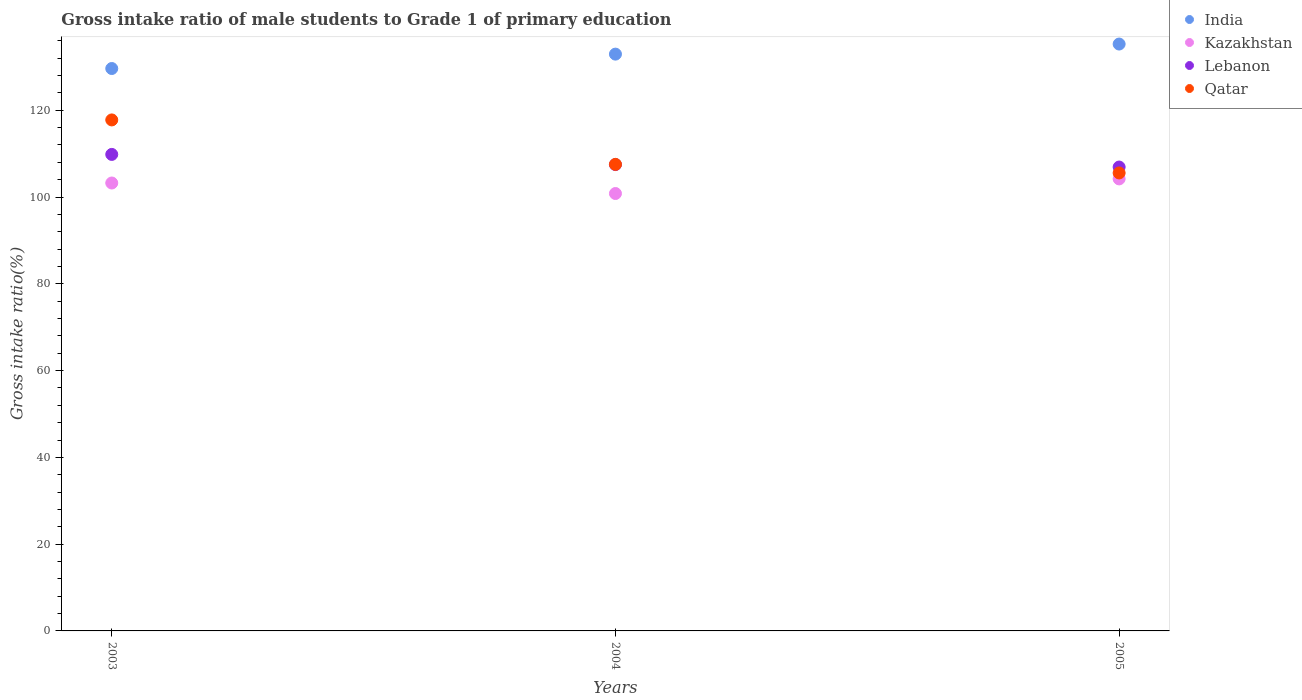How many different coloured dotlines are there?
Provide a short and direct response. 4. What is the gross intake ratio in Lebanon in 2004?
Provide a short and direct response. 107.49. Across all years, what is the maximum gross intake ratio in Kazakhstan?
Make the answer very short. 104.18. Across all years, what is the minimum gross intake ratio in Qatar?
Offer a terse response. 105.56. What is the total gross intake ratio in Lebanon in the graph?
Provide a succinct answer. 324.24. What is the difference between the gross intake ratio in Qatar in 2003 and that in 2004?
Ensure brevity in your answer.  10.24. What is the difference between the gross intake ratio in Lebanon in 2004 and the gross intake ratio in Qatar in 2003?
Give a very brief answer. -10.29. What is the average gross intake ratio in Lebanon per year?
Make the answer very short. 108.08. In the year 2005, what is the difference between the gross intake ratio in India and gross intake ratio in Qatar?
Keep it short and to the point. 29.71. In how many years, is the gross intake ratio in Lebanon greater than 88 %?
Your answer should be very brief. 3. What is the ratio of the gross intake ratio in Qatar in 2003 to that in 2005?
Provide a short and direct response. 1.12. Is the difference between the gross intake ratio in India in 2004 and 2005 greater than the difference between the gross intake ratio in Qatar in 2004 and 2005?
Give a very brief answer. No. What is the difference between the highest and the second highest gross intake ratio in Lebanon?
Offer a very short reply. 2.34. What is the difference between the highest and the lowest gross intake ratio in Kazakhstan?
Keep it short and to the point. 3.37. Is the sum of the gross intake ratio in Kazakhstan in 2004 and 2005 greater than the maximum gross intake ratio in Qatar across all years?
Ensure brevity in your answer.  Yes. Is it the case that in every year, the sum of the gross intake ratio in India and gross intake ratio in Lebanon  is greater than the sum of gross intake ratio in Qatar and gross intake ratio in Kazakhstan?
Give a very brief answer. Yes. Is the gross intake ratio in Qatar strictly greater than the gross intake ratio in Lebanon over the years?
Keep it short and to the point. No. How many dotlines are there?
Your answer should be compact. 4. What is the difference between two consecutive major ticks on the Y-axis?
Offer a terse response. 20. Does the graph contain any zero values?
Give a very brief answer. No. Does the graph contain grids?
Provide a short and direct response. No. Where does the legend appear in the graph?
Provide a succinct answer. Top right. What is the title of the graph?
Offer a terse response. Gross intake ratio of male students to Grade 1 of primary education. Does "Mali" appear as one of the legend labels in the graph?
Your answer should be compact. No. What is the label or title of the Y-axis?
Your answer should be compact. Gross intake ratio(%). What is the Gross intake ratio(%) in India in 2003?
Your response must be concise. 129.63. What is the Gross intake ratio(%) of Kazakhstan in 2003?
Give a very brief answer. 103.24. What is the Gross intake ratio(%) in Lebanon in 2003?
Your response must be concise. 109.83. What is the Gross intake ratio(%) in Qatar in 2003?
Keep it short and to the point. 117.78. What is the Gross intake ratio(%) of India in 2004?
Make the answer very short. 132.94. What is the Gross intake ratio(%) in Kazakhstan in 2004?
Give a very brief answer. 100.82. What is the Gross intake ratio(%) in Lebanon in 2004?
Ensure brevity in your answer.  107.49. What is the Gross intake ratio(%) of Qatar in 2004?
Your answer should be compact. 107.53. What is the Gross intake ratio(%) in India in 2005?
Ensure brevity in your answer.  135.27. What is the Gross intake ratio(%) in Kazakhstan in 2005?
Provide a succinct answer. 104.18. What is the Gross intake ratio(%) in Lebanon in 2005?
Provide a short and direct response. 106.92. What is the Gross intake ratio(%) of Qatar in 2005?
Your answer should be very brief. 105.56. Across all years, what is the maximum Gross intake ratio(%) in India?
Make the answer very short. 135.27. Across all years, what is the maximum Gross intake ratio(%) of Kazakhstan?
Offer a very short reply. 104.18. Across all years, what is the maximum Gross intake ratio(%) in Lebanon?
Offer a very short reply. 109.83. Across all years, what is the maximum Gross intake ratio(%) in Qatar?
Your answer should be compact. 117.78. Across all years, what is the minimum Gross intake ratio(%) of India?
Provide a succinct answer. 129.63. Across all years, what is the minimum Gross intake ratio(%) of Kazakhstan?
Your answer should be very brief. 100.82. Across all years, what is the minimum Gross intake ratio(%) of Lebanon?
Offer a very short reply. 106.92. Across all years, what is the minimum Gross intake ratio(%) in Qatar?
Keep it short and to the point. 105.56. What is the total Gross intake ratio(%) in India in the graph?
Your answer should be compact. 397.84. What is the total Gross intake ratio(%) of Kazakhstan in the graph?
Offer a very short reply. 308.24. What is the total Gross intake ratio(%) of Lebanon in the graph?
Give a very brief answer. 324.24. What is the total Gross intake ratio(%) of Qatar in the graph?
Offer a terse response. 330.87. What is the difference between the Gross intake ratio(%) of India in 2003 and that in 2004?
Your response must be concise. -3.32. What is the difference between the Gross intake ratio(%) in Kazakhstan in 2003 and that in 2004?
Offer a terse response. 2.42. What is the difference between the Gross intake ratio(%) of Lebanon in 2003 and that in 2004?
Provide a succinct answer. 2.34. What is the difference between the Gross intake ratio(%) of Qatar in 2003 and that in 2004?
Provide a succinct answer. 10.24. What is the difference between the Gross intake ratio(%) of India in 2003 and that in 2005?
Your answer should be compact. -5.64. What is the difference between the Gross intake ratio(%) in Kazakhstan in 2003 and that in 2005?
Make the answer very short. -0.94. What is the difference between the Gross intake ratio(%) of Lebanon in 2003 and that in 2005?
Your answer should be very brief. 2.91. What is the difference between the Gross intake ratio(%) in Qatar in 2003 and that in 2005?
Your answer should be very brief. 12.22. What is the difference between the Gross intake ratio(%) of India in 2004 and that in 2005?
Your answer should be very brief. -2.32. What is the difference between the Gross intake ratio(%) in Kazakhstan in 2004 and that in 2005?
Your answer should be very brief. -3.37. What is the difference between the Gross intake ratio(%) of Lebanon in 2004 and that in 2005?
Make the answer very short. 0.57. What is the difference between the Gross intake ratio(%) in Qatar in 2004 and that in 2005?
Offer a terse response. 1.98. What is the difference between the Gross intake ratio(%) in India in 2003 and the Gross intake ratio(%) in Kazakhstan in 2004?
Offer a very short reply. 28.81. What is the difference between the Gross intake ratio(%) in India in 2003 and the Gross intake ratio(%) in Lebanon in 2004?
Provide a short and direct response. 22.14. What is the difference between the Gross intake ratio(%) in India in 2003 and the Gross intake ratio(%) in Qatar in 2004?
Keep it short and to the point. 22.09. What is the difference between the Gross intake ratio(%) in Kazakhstan in 2003 and the Gross intake ratio(%) in Lebanon in 2004?
Make the answer very short. -4.25. What is the difference between the Gross intake ratio(%) of Kazakhstan in 2003 and the Gross intake ratio(%) of Qatar in 2004?
Your answer should be very brief. -4.29. What is the difference between the Gross intake ratio(%) of Lebanon in 2003 and the Gross intake ratio(%) of Qatar in 2004?
Make the answer very short. 2.3. What is the difference between the Gross intake ratio(%) in India in 2003 and the Gross intake ratio(%) in Kazakhstan in 2005?
Make the answer very short. 25.44. What is the difference between the Gross intake ratio(%) in India in 2003 and the Gross intake ratio(%) in Lebanon in 2005?
Offer a very short reply. 22.71. What is the difference between the Gross intake ratio(%) in India in 2003 and the Gross intake ratio(%) in Qatar in 2005?
Provide a succinct answer. 24.07. What is the difference between the Gross intake ratio(%) of Kazakhstan in 2003 and the Gross intake ratio(%) of Lebanon in 2005?
Offer a very short reply. -3.68. What is the difference between the Gross intake ratio(%) of Kazakhstan in 2003 and the Gross intake ratio(%) of Qatar in 2005?
Keep it short and to the point. -2.32. What is the difference between the Gross intake ratio(%) in Lebanon in 2003 and the Gross intake ratio(%) in Qatar in 2005?
Offer a terse response. 4.27. What is the difference between the Gross intake ratio(%) in India in 2004 and the Gross intake ratio(%) in Kazakhstan in 2005?
Make the answer very short. 28.76. What is the difference between the Gross intake ratio(%) in India in 2004 and the Gross intake ratio(%) in Lebanon in 2005?
Give a very brief answer. 26.03. What is the difference between the Gross intake ratio(%) in India in 2004 and the Gross intake ratio(%) in Qatar in 2005?
Make the answer very short. 27.39. What is the difference between the Gross intake ratio(%) of Kazakhstan in 2004 and the Gross intake ratio(%) of Lebanon in 2005?
Keep it short and to the point. -6.1. What is the difference between the Gross intake ratio(%) of Kazakhstan in 2004 and the Gross intake ratio(%) of Qatar in 2005?
Provide a succinct answer. -4.74. What is the difference between the Gross intake ratio(%) of Lebanon in 2004 and the Gross intake ratio(%) of Qatar in 2005?
Offer a terse response. 1.93. What is the average Gross intake ratio(%) of India per year?
Your answer should be compact. 132.61. What is the average Gross intake ratio(%) in Kazakhstan per year?
Your answer should be compact. 102.75. What is the average Gross intake ratio(%) in Lebanon per year?
Provide a succinct answer. 108.08. What is the average Gross intake ratio(%) of Qatar per year?
Your response must be concise. 110.29. In the year 2003, what is the difference between the Gross intake ratio(%) of India and Gross intake ratio(%) of Kazakhstan?
Offer a terse response. 26.39. In the year 2003, what is the difference between the Gross intake ratio(%) in India and Gross intake ratio(%) in Lebanon?
Provide a succinct answer. 19.8. In the year 2003, what is the difference between the Gross intake ratio(%) of India and Gross intake ratio(%) of Qatar?
Your answer should be very brief. 11.85. In the year 2003, what is the difference between the Gross intake ratio(%) of Kazakhstan and Gross intake ratio(%) of Lebanon?
Give a very brief answer. -6.59. In the year 2003, what is the difference between the Gross intake ratio(%) of Kazakhstan and Gross intake ratio(%) of Qatar?
Keep it short and to the point. -14.54. In the year 2003, what is the difference between the Gross intake ratio(%) in Lebanon and Gross intake ratio(%) in Qatar?
Provide a short and direct response. -7.95. In the year 2004, what is the difference between the Gross intake ratio(%) in India and Gross intake ratio(%) in Kazakhstan?
Make the answer very short. 32.13. In the year 2004, what is the difference between the Gross intake ratio(%) in India and Gross intake ratio(%) in Lebanon?
Your answer should be very brief. 25.46. In the year 2004, what is the difference between the Gross intake ratio(%) of India and Gross intake ratio(%) of Qatar?
Make the answer very short. 25.41. In the year 2004, what is the difference between the Gross intake ratio(%) of Kazakhstan and Gross intake ratio(%) of Lebanon?
Offer a very short reply. -6.67. In the year 2004, what is the difference between the Gross intake ratio(%) of Kazakhstan and Gross intake ratio(%) of Qatar?
Keep it short and to the point. -6.72. In the year 2004, what is the difference between the Gross intake ratio(%) of Lebanon and Gross intake ratio(%) of Qatar?
Keep it short and to the point. -0.04. In the year 2005, what is the difference between the Gross intake ratio(%) of India and Gross intake ratio(%) of Kazakhstan?
Make the answer very short. 31.08. In the year 2005, what is the difference between the Gross intake ratio(%) of India and Gross intake ratio(%) of Lebanon?
Give a very brief answer. 28.35. In the year 2005, what is the difference between the Gross intake ratio(%) of India and Gross intake ratio(%) of Qatar?
Ensure brevity in your answer.  29.71. In the year 2005, what is the difference between the Gross intake ratio(%) of Kazakhstan and Gross intake ratio(%) of Lebanon?
Your answer should be very brief. -2.74. In the year 2005, what is the difference between the Gross intake ratio(%) in Kazakhstan and Gross intake ratio(%) in Qatar?
Give a very brief answer. -1.37. In the year 2005, what is the difference between the Gross intake ratio(%) in Lebanon and Gross intake ratio(%) in Qatar?
Your response must be concise. 1.36. What is the ratio of the Gross intake ratio(%) in India in 2003 to that in 2004?
Your answer should be very brief. 0.97. What is the ratio of the Gross intake ratio(%) of Lebanon in 2003 to that in 2004?
Ensure brevity in your answer.  1.02. What is the ratio of the Gross intake ratio(%) of Qatar in 2003 to that in 2004?
Provide a short and direct response. 1.1. What is the ratio of the Gross intake ratio(%) of India in 2003 to that in 2005?
Your response must be concise. 0.96. What is the ratio of the Gross intake ratio(%) of Kazakhstan in 2003 to that in 2005?
Provide a succinct answer. 0.99. What is the ratio of the Gross intake ratio(%) of Lebanon in 2003 to that in 2005?
Your answer should be very brief. 1.03. What is the ratio of the Gross intake ratio(%) in Qatar in 2003 to that in 2005?
Your answer should be compact. 1.12. What is the ratio of the Gross intake ratio(%) of India in 2004 to that in 2005?
Your answer should be very brief. 0.98. What is the ratio of the Gross intake ratio(%) in Kazakhstan in 2004 to that in 2005?
Provide a succinct answer. 0.97. What is the ratio of the Gross intake ratio(%) in Qatar in 2004 to that in 2005?
Offer a very short reply. 1.02. What is the difference between the highest and the second highest Gross intake ratio(%) of India?
Ensure brevity in your answer.  2.32. What is the difference between the highest and the second highest Gross intake ratio(%) in Lebanon?
Give a very brief answer. 2.34. What is the difference between the highest and the second highest Gross intake ratio(%) of Qatar?
Provide a succinct answer. 10.24. What is the difference between the highest and the lowest Gross intake ratio(%) of India?
Offer a terse response. 5.64. What is the difference between the highest and the lowest Gross intake ratio(%) in Kazakhstan?
Give a very brief answer. 3.37. What is the difference between the highest and the lowest Gross intake ratio(%) in Lebanon?
Offer a terse response. 2.91. What is the difference between the highest and the lowest Gross intake ratio(%) of Qatar?
Offer a terse response. 12.22. 